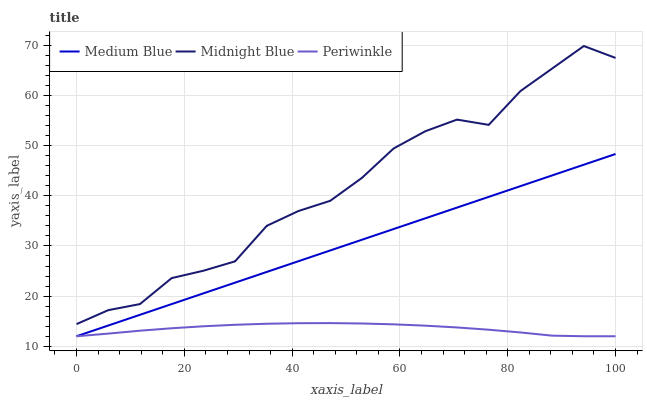Does Periwinkle have the minimum area under the curve?
Answer yes or no. Yes. Does Midnight Blue have the maximum area under the curve?
Answer yes or no. Yes. Does Medium Blue have the minimum area under the curve?
Answer yes or no. No. Does Medium Blue have the maximum area under the curve?
Answer yes or no. No. Is Medium Blue the smoothest?
Answer yes or no. Yes. Is Midnight Blue the roughest?
Answer yes or no. Yes. Is Midnight Blue the smoothest?
Answer yes or no. No. Is Medium Blue the roughest?
Answer yes or no. No. Does Midnight Blue have the lowest value?
Answer yes or no. No. Does Medium Blue have the highest value?
Answer yes or no. No. Is Medium Blue less than Midnight Blue?
Answer yes or no. Yes. Is Midnight Blue greater than Periwinkle?
Answer yes or no. Yes. Does Medium Blue intersect Midnight Blue?
Answer yes or no. No. 